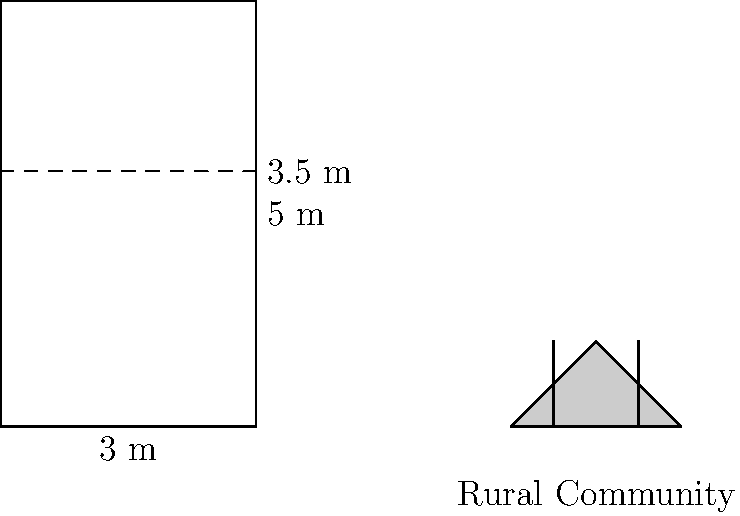A cylindrical water tank in a rural community in Bihar has a diameter of 3 meters and a height of 5 meters. The tank is currently filled to a height of 3.5 meters. How many more liters of water can be added to the tank before it reaches its full capacity? (Use $\pi = 3.14$ for calculations) Let's approach this step-by-step:

1) First, we need to calculate the volume of the entire tank:
   Volume of cylinder = $\pi r^2 h$
   where $r$ is the radius and $h$ is the height.
   
   Radius = Diameter / 2 = 3 m / 2 = 1.5 m
   
   Full volume = $3.14 \times (1.5\text{ m})^2 \times 5\text{ m} = 35.325\text{ m}^3$

2) Now, let's calculate the volume of water currently in the tank:
   Current water volume = $3.14 \times (1.5\text{ m})^2 \times 3.5\text{ m} = 24.7275\text{ m}^3$

3) The additional volume that can be added is the difference between these:
   Additional volume = $35.325\text{ m}^3 - 24.7275\text{ m}^3 = 10.5975\text{ m}^3$

4) We need to convert this to liters:
   1 m³ = 1000 liters
   Additional volume in liters = $10.5975\text{ m}^3 \times 1000\text{ L/m}^3 = 10597.5\text{ L}$

Therefore, 10597.5 liters of water can be added to the tank before it reaches full capacity.
Answer: 10597.5 liters 